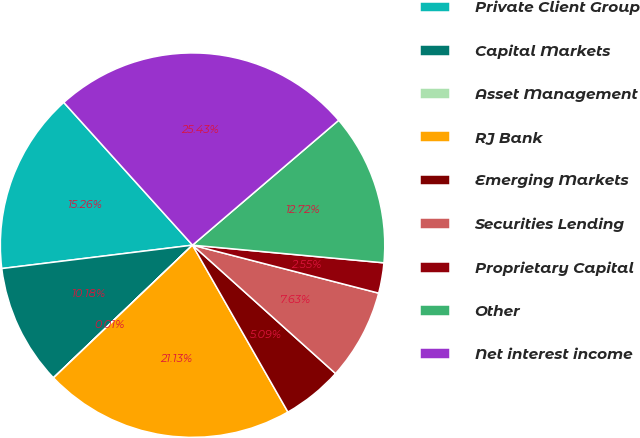Convert chart to OTSL. <chart><loc_0><loc_0><loc_500><loc_500><pie_chart><fcel>Private Client Group<fcel>Capital Markets<fcel>Asset Management<fcel>RJ Bank<fcel>Emerging Markets<fcel>Securities Lending<fcel>Proprietary Capital<fcel>Other<fcel>Net interest income<nl><fcel>15.26%<fcel>10.18%<fcel>0.01%<fcel>21.13%<fcel>5.09%<fcel>7.63%<fcel>2.55%<fcel>12.72%<fcel>25.43%<nl></chart> 